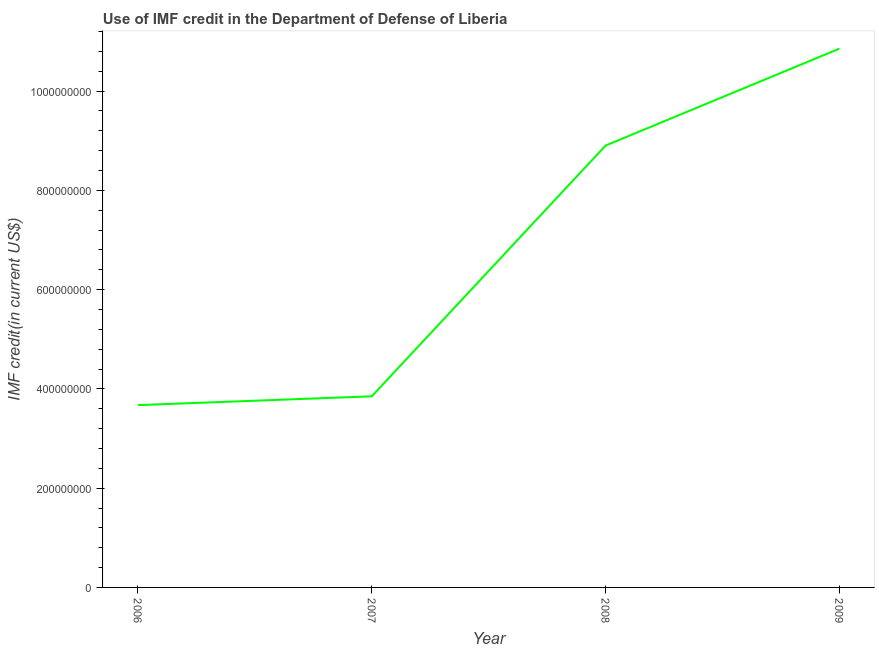What is the use of imf credit in dod in 2008?
Provide a short and direct response. 8.90e+08. Across all years, what is the maximum use of imf credit in dod?
Keep it short and to the point. 1.09e+09. Across all years, what is the minimum use of imf credit in dod?
Ensure brevity in your answer.  3.67e+08. What is the sum of the use of imf credit in dod?
Ensure brevity in your answer.  2.73e+09. What is the difference between the use of imf credit in dod in 2006 and 2008?
Provide a succinct answer. -5.23e+08. What is the average use of imf credit in dod per year?
Your answer should be very brief. 6.82e+08. What is the median use of imf credit in dod?
Offer a terse response. 6.38e+08. Do a majority of the years between 2006 and 2008 (inclusive) have use of imf credit in dod greater than 640000000 US$?
Offer a very short reply. No. What is the ratio of the use of imf credit in dod in 2006 to that in 2008?
Keep it short and to the point. 0.41. Is the difference between the use of imf credit in dod in 2006 and 2008 greater than the difference between any two years?
Keep it short and to the point. No. What is the difference between the highest and the second highest use of imf credit in dod?
Give a very brief answer. 1.95e+08. What is the difference between the highest and the lowest use of imf credit in dod?
Your response must be concise. 7.18e+08. In how many years, is the use of imf credit in dod greater than the average use of imf credit in dod taken over all years?
Offer a terse response. 2. Does the use of imf credit in dod monotonically increase over the years?
Offer a terse response. Yes. Are the values on the major ticks of Y-axis written in scientific E-notation?
Offer a very short reply. No. Does the graph contain grids?
Make the answer very short. No. What is the title of the graph?
Your response must be concise. Use of IMF credit in the Department of Defense of Liberia. What is the label or title of the X-axis?
Your response must be concise. Year. What is the label or title of the Y-axis?
Offer a terse response. IMF credit(in current US$). What is the IMF credit(in current US$) of 2006?
Ensure brevity in your answer.  3.67e+08. What is the IMF credit(in current US$) of 2007?
Offer a terse response. 3.85e+08. What is the IMF credit(in current US$) in 2008?
Provide a short and direct response. 8.90e+08. What is the IMF credit(in current US$) of 2009?
Ensure brevity in your answer.  1.09e+09. What is the difference between the IMF credit(in current US$) in 2006 and 2007?
Make the answer very short. -1.78e+07. What is the difference between the IMF credit(in current US$) in 2006 and 2008?
Offer a very short reply. -5.23e+08. What is the difference between the IMF credit(in current US$) in 2006 and 2009?
Keep it short and to the point. -7.18e+08. What is the difference between the IMF credit(in current US$) in 2007 and 2008?
Offer a terse response. -5.05e+08. What is the difference between the IMF credit(in current US$) in 2007 and 2009?
Keep it short and to the point. -7.00e+08. What is the difference between the IMF credit(in current US$) in 2008 and 2009?
Your answer should be very brief. -1.95e+08. What is the ratio of the IMF credit(in current US$) in 2006 to that in 2007?
Ensure brevity in your answer.  0.95. What is the ratio of the IMF credit(in current US$) in 2006 to that in 2008?
Make the answer very short. 0.41. What is the ratio of the IMF credit(in current US$) in 2006 to that in 2009?
Offer a terse response. 0.34. What is the ratio of the IMF credit(in current US$) in 2007 to that in 2008?
Ensure brevity in your answer.  0.43. What is the ratio of the IMF credit(in current US$) in 2007 to that in 2009?
Provide a succinct answer. 0.35. What is the ratio of the IMF credit(in current US$) in 2008 to that in 2009?
Keep it short and to the point. 0.82. 